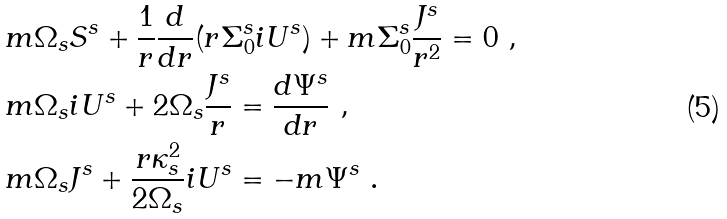Convert formula to latex. <formula><loc_0><loc_0><loc_500><loc_500>& m \Omega _ { s } S ^ { s } + \frac { 1 } { r } \frac { d } { d r } ( r \Sigma _ { 0 } ^ { s } i U ^ { s } ) + m \Sigma _ { 0 } ^ { s } \frac { J ^ { s } } { r ^ { 2 } } = 0 \ , \\ & m \Omega _ { s } i U ^ { s } + 2 \Omega _ { s } \frac { J ^ { s } } { r } = \frac { d \Psi ^ { s } } { d r } \ , \\ & m \Omega _ { s } J ^ { s } + \frac { r \kappa _ { s } ^ { 2 } } { 2 \Omega _ { s } } i U ^ { s } = - m \Psi ^ { s } \ .</formula> 